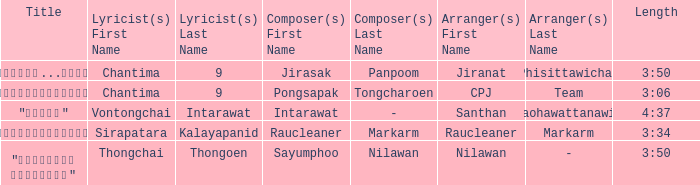Who was the arranger of "ขอโทษ"? Santhan Laohawattanawit. Could you help me parse every detail presented in this table? {'header': ['Title', 'Lyricist(s) First Name', 'Lyricist(s) Last Name', 'Composer(s) First Name', 'Composer(s) Last Name', 'Arranger(s) First Name', 'Arranger(s) Last Name', 'Length'], 'rows': [['"เรายังรักกัน...ไม่ใช่เหรอ"', 'Chantima', '9', 'Jirasak', 'Panpoom', 'Jiranat', 'Phisittawichai', '3:50'], ['"นางฟ้าตาชั้นเดียว"', 'Chantima', '9', 'Pongsapak', 'Tongcharoen', 'CPJ', 'Team', '3:06'], ['"ขอโทษ"', 'Vontongchai', 'Intarawat', 'Intarawat', '-', 'Santhan', 'Laohawattanawit', '4:37'], ['"แค่อยากให้รู้"', 'Sirapatara', 'Kalayapanid', 'Raucleaner', 'Markarm', 'Raucleaner', 'Markarm', '3:34'], ['"เลือกลืม เลือกจำ"', 'Thongchai', 'Thongoen', 'Sayumphoo', 'Nilawan', 'Nilawan', '-', '3:50']]} 